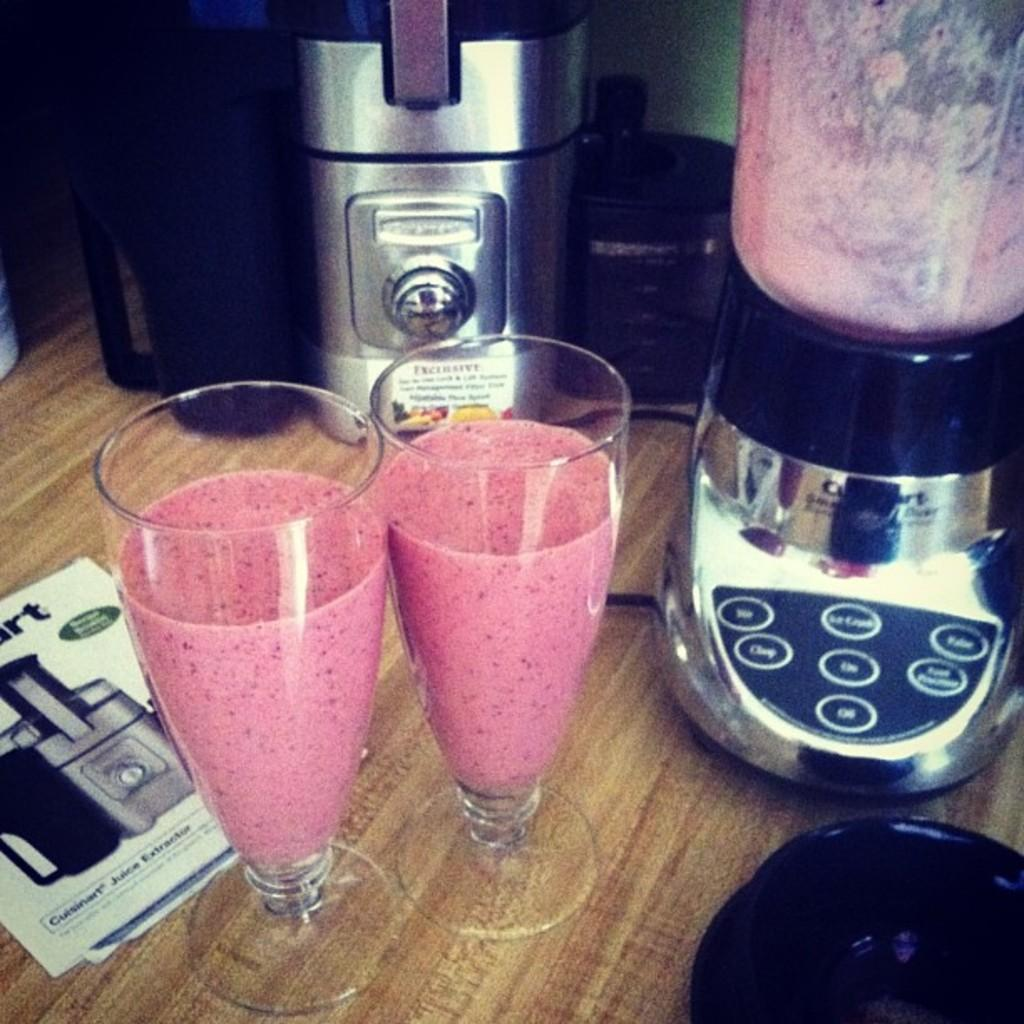<image>
Provide a brief description of the given image. A Cuisinart blender has two glasses full of smoothies sitting next to it. 